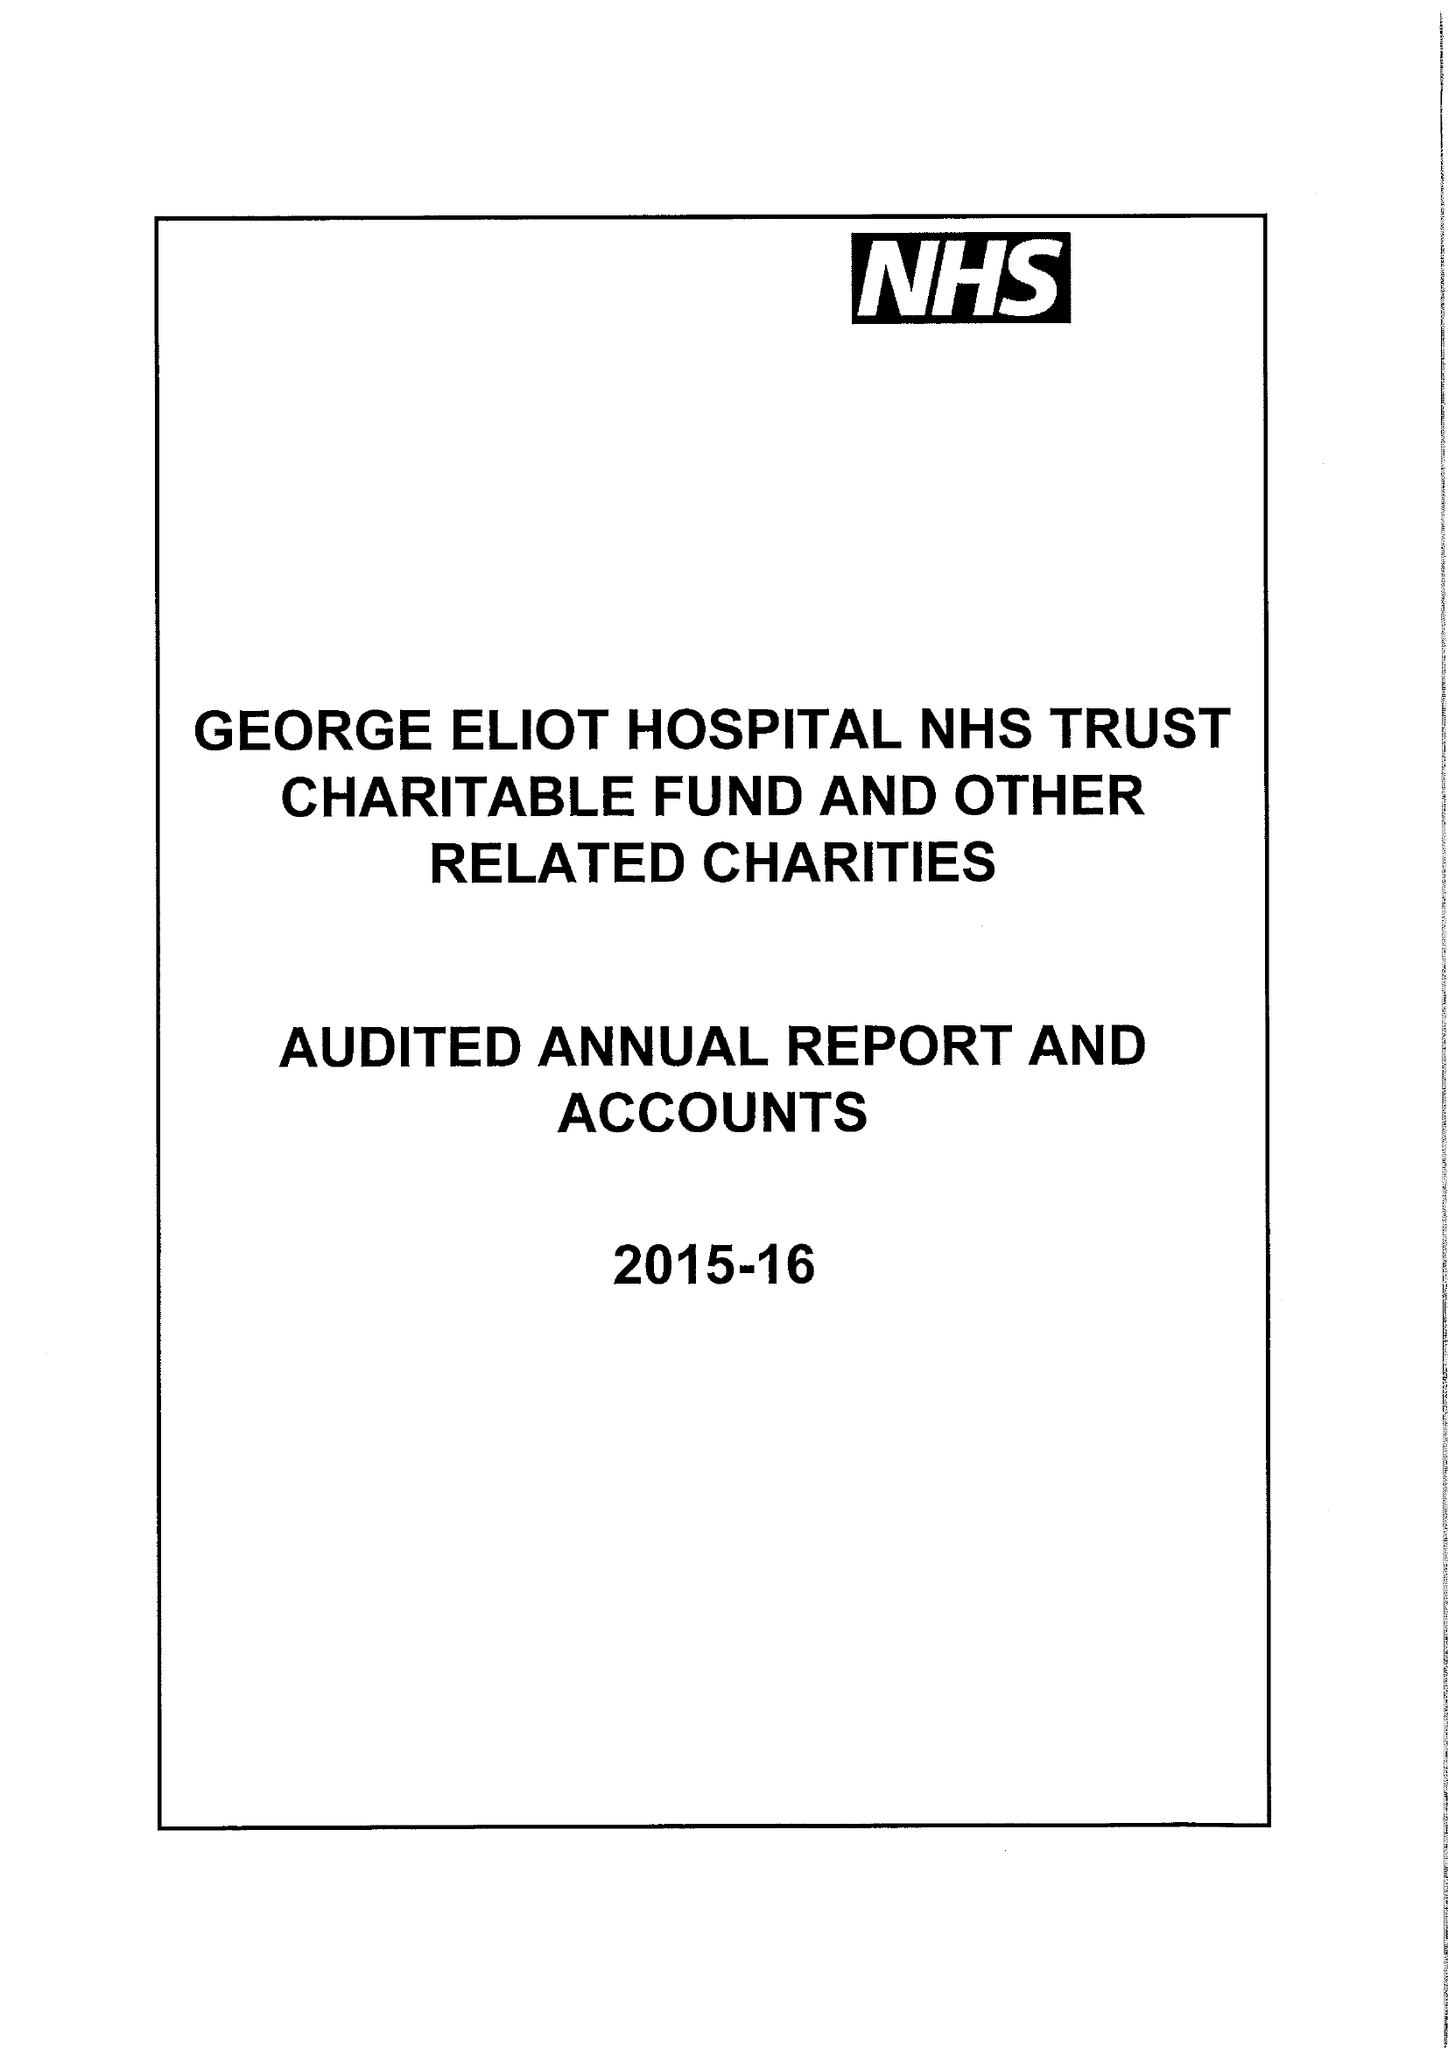What is the value for the charity_number?
Answer the question using a single word or phrase. 1057607 